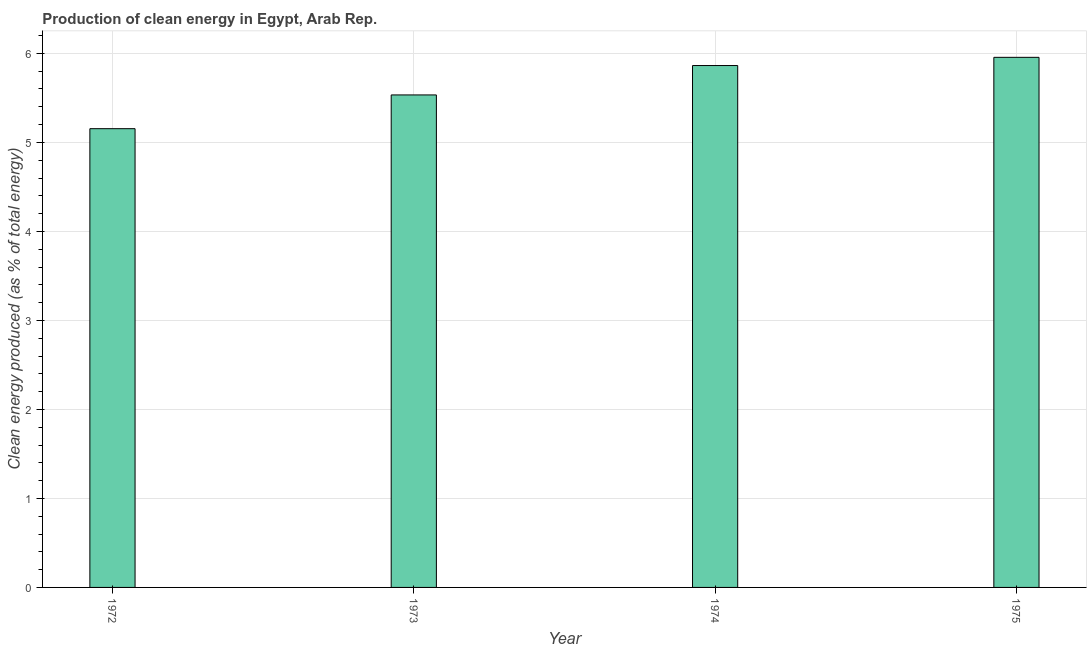Does the graph contain grids?
Give a very brief answer. Yes. What is the title of the graph?
Provide a short and direct response. Production of clean energy in Egypt, Arab Rep. What is the label or title of the Y-axis?
Offer a terse response. Clean energy produced (as % of total energy). What is the production of clean energy in 1973?
Provide a succinct answer. 5.53. Across all years, what is the maximum production of clean energy?
Your response must be concise. 5.96. Across all years, what is the minimum production of clean energy?
Ensure brevity in your answer.  5.15. In which year was the production of clean energy maximum?
Your answer should be compact. 1975. In which year was the production of clean energy minimum?
Your response must be concise. 1972. What is the sum of the production of clean energy?
Ensure brevity in your answer.  22.51. What is the difference between the production of clean energy in 1972 and 1975?
Keep it short and to the point. -0.8. What is the average production of clean energy per year?
Your answer should be compact. 5.63. What is the median production of clean energy?
Your response must be concise. 5.7. In how many years, is the production of clean energy greater than 1.8 %?
Provide a short and direct response. 4. What is the ratio of the production of clean energy in 1972 to that in 1973?
Offer a terse response. 0.93. Is the production of clean energy in 1972 less than that in 1974?
Give a very brief answer. Yes. Is the difference between the production of clean energy in 1973 and 1974 greater than the difference between any two years?
Offer a terse response. No. What is the difference between the highest and the second highest production of clean energy?
Your response must be concise. 0.09. How many years are there in the graph?
Offer a very short reply. 4. Are the values on the major ticks of Y-axis written in scientific E-notation?
Offer a very short reply. No. What is the Clean energy produced (as % of total energy) of 1972?
Offer a terse response. 5.15. What is the Clean energy produced (as % of total energy) in 1973?
Offer a very short reply. 5.53. What is the Clean energy produced (as % of total energy) in 1974?
Give a very brief answer. 5.86. What is the Clean energy produced (as % of total energy) in 1975?
Make the answer very short. 5.96. What is the difference between the Clean energy produced (as % of total energy) in 1972 and 1973?
Make the answer very short. -0.38. What is the difference between the Clean energy produced (as % of total energy) in 1972 and 1974?
Ensure brevity in your answer.  -0.71. What is the difference between the Clean energy produced (as % of total energy) in 1972 and 1975?
Provide a succinct answer. -0.8. What is the difference between the Clean energy produced (as % of total energy) in 1973 and 1974?
Your answer should be compact. -0.33. What is the difference between the Clean energy produced (as % of total energy) in 1973 and 1975?
Provide a short and direct response. -0.42. What is the difference between the Clean energy produced (as % of total energy) in 1974 and 1975?
Offer a very short reply. -0.09. What is the ratio of the Clean energy produced (as % of total energy) in 1972 to that in 1974?
Your response must be concise. 0.88. What is the ratio of the Clean energy produced (as % of total energy) in 1972 to that in 1975?
Your answer should be compact. 0.86. What is the ratio of the Clean energy produced (as % of total energy) in 1973 to that in 1974?
Your answer should be compact. 0.94. What is the ratio of the Clean energy produced (as % of total energy) in 1973 to that in 1975?
Offer a terse response. 0.93. 